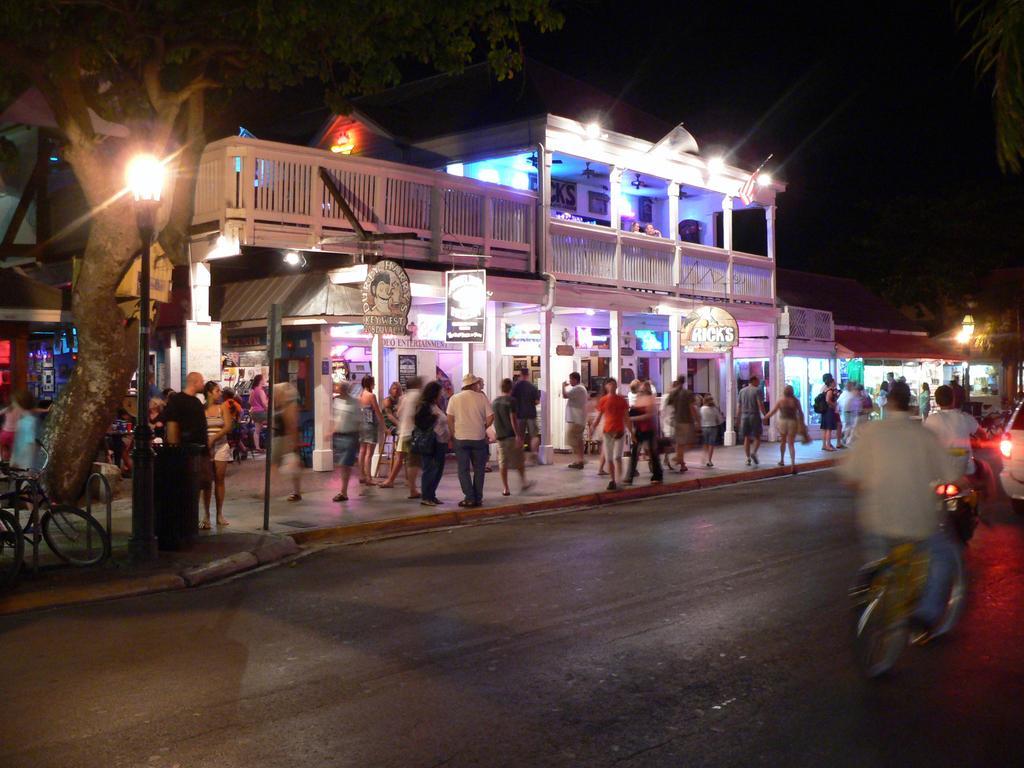How would you summarize this image in a sentence or two? In this picture we can see some vehicles on the path and on the left side vehicles there are groups of people, poles with lights, dustbin, trees and a building. Behind the building there is a dark background. 